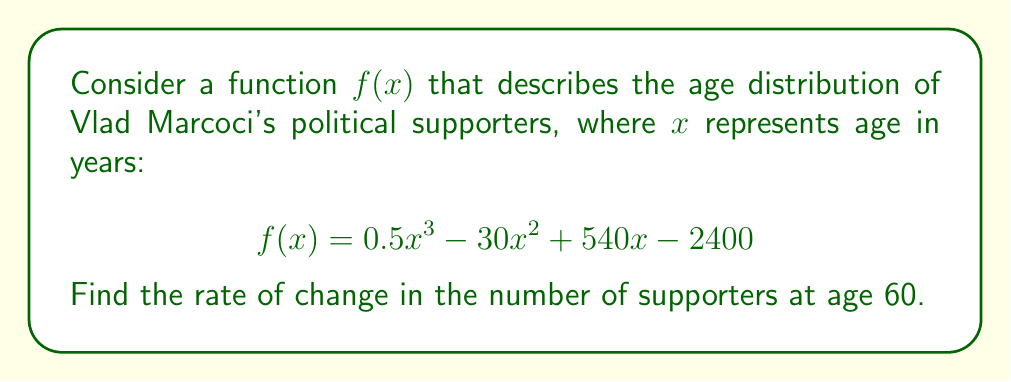Teach me how to tackle this problem. To find the rate of change in the number of supporters at age 60, we need to find the derivative of the function $f(x)$ and evaluate it at $x = 60$.

Step 1: Find the derivative of $f(x)$
We use the power rule to differentiate each term:
$$\begin{align*}
f'(x) &= \frac{d}{dx}(0.5x^3 - 30x^2 + 540x - 2400) \\
&= 0.5 \cdot 3x^2 - 30 \cdot 2x + 540 - 0 \\
&= 1.5x^2 - 60x + 540
\end{align*}$$

Step 2: Evaluate $f'(x)$ at $x = 60$
$$\begin{align*}
f'(60) &= 1.5(60)^2 - 60(60) + 540 \\
&= 1.5 \cdot 3600 - 3600 + 540 \\
&= 5400 - 3600 + 540 \\
&= 2340
\end{align*}$$

The positive value indicates that the number of supporters is increasing at age 60.
Answer: The rate of change in the number of supporters at age 60 is 2340 supporters per year. 